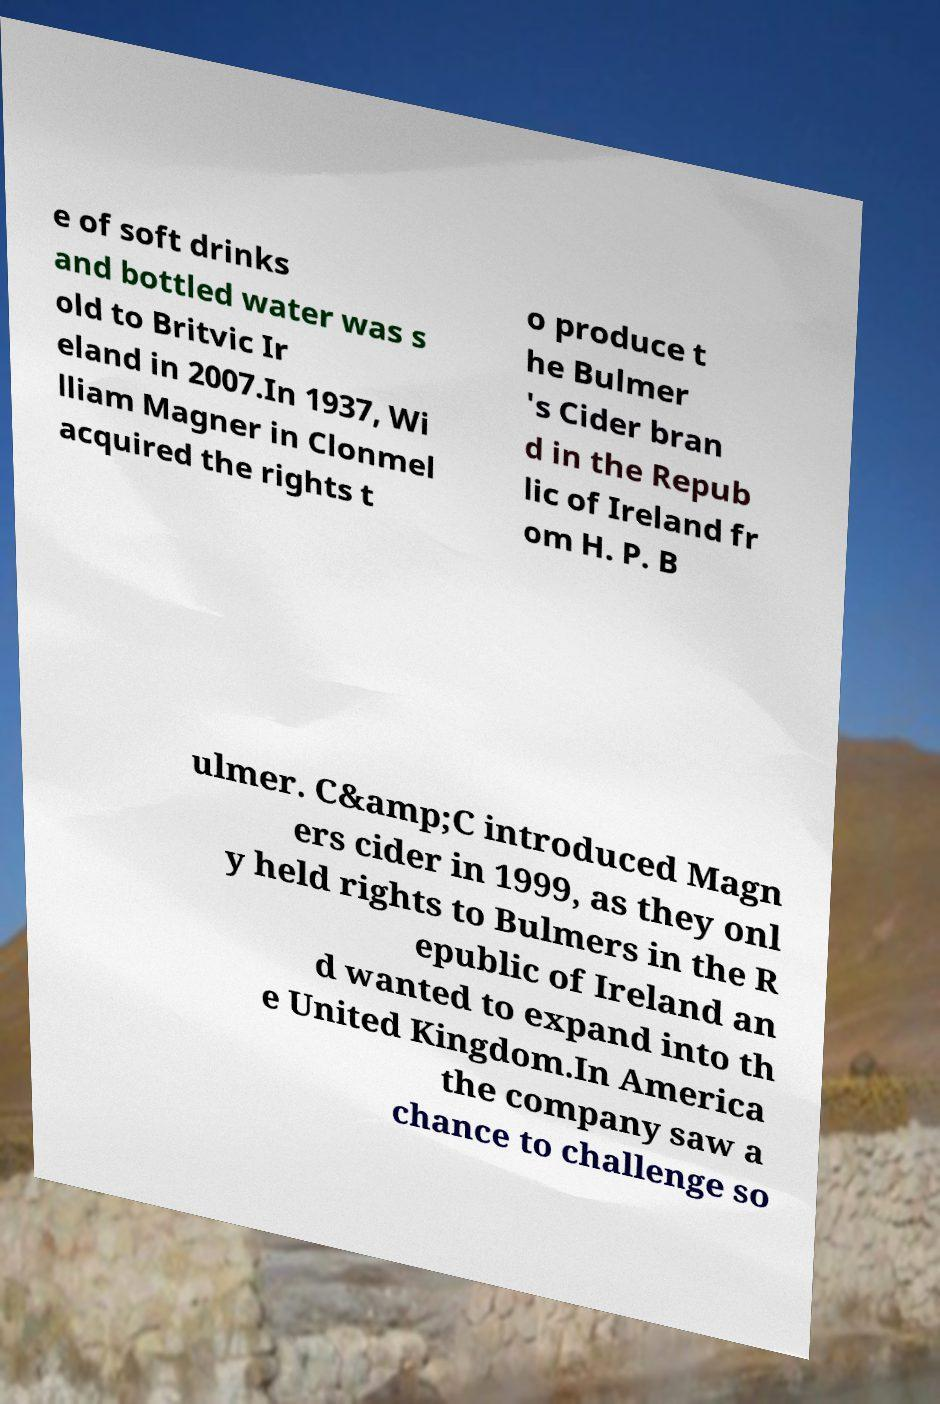For documentation purposes, I need the text within this image transcribed. Could you provide that? e of soft drinks and bottled water was s old to Britvic Ir eland in 2007.In 1937, Wi lliam Magner in Clonmel acquired the rights t o produce t he Bulmer 's Cider bran d in the Repub lic of Ireland fr om H. P. B ulmer. C&amp;C introduced Magn ers cider in 1999, as they onl y held rights to Bulmers in the R epublic of Ireland an d wanted to expand into th e United Kingdom.In America the company saw a chance to challenge so 